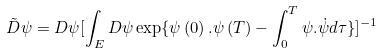<formula> <loc_0><loc_0><loc_500><loc_500>\tilde { D } \psi = D \psi [ \int _ { E } D \psi \exp \{ \psi \left ( 0 \right ) . \psi \left ( T \right ) - \int _ { 0 } ^ { T } \psi . \dot { \psi } d \tau \} ] ^ { - 1 }</formula> 